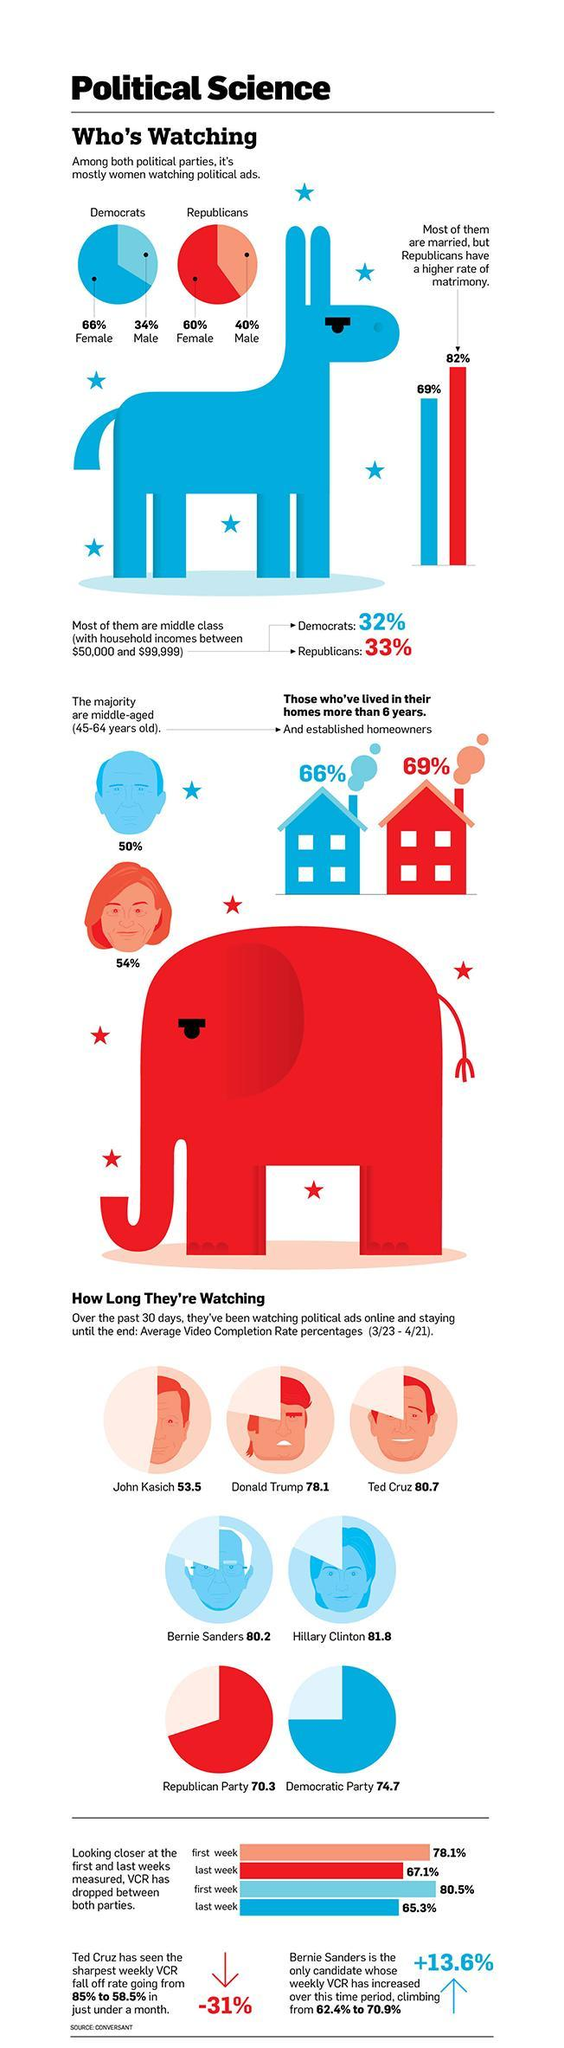What percent of the democrats are middle class with household income between $50,000 & $99,999?
Answer the question with a short phrase. 32% What percentage of democratic women watch political ads according to the survey? 66% What is the matrimony rate in Democrats as per the survey? 69% Which political party people have a lower rate of matrimony as per the survey? Democrats What percentage of republican women watch political ads according to the survey? 60% What percentage of republican women are in the age group of 45-64 years old as per the survey? 54% 